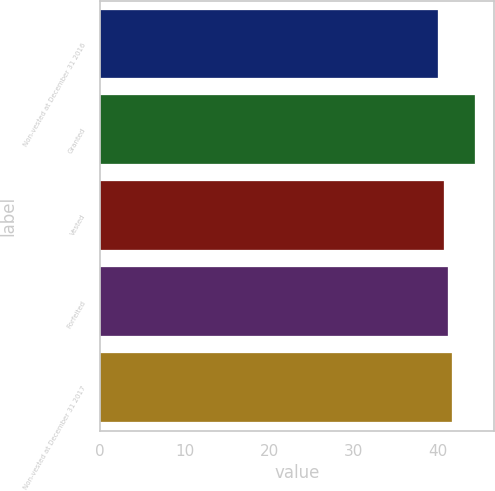<chart> <loc_0><loc_0><loc_500><loc_500><bar_chart><fcel>Non-vested at December 31 2016<fcel>Granted<fcel>Vested<fcel>Forfeited<fcel>Non-vested at December 31 2017<nl><fcel>40.03<fcel>44.38<fcel>40.74<fcel>41.18<fcel>41.62<nl></chart> 